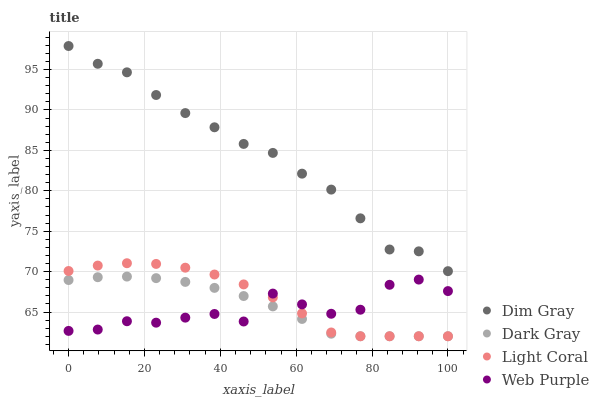Does Web Purple have the minimum area under the curve?
Answer yes or no. Yes. Does Dim Gray have the maximum area under the curve?
Answer yes or no. Yes. Does Light Coral have the minimum area under the curve?
Answer yes or no. No. Does Light Coral have the maximum area under the curve?
Answer yes or no. No. Is Dark Gray the smoothest?
Answer yes or no. Yes. Is Web Purple the roughest?
Answer yes or no. Yes. Is Light Coral the smoothest?
Answer yes or no. No. Is Light Coral the roughest?
Answer yes or no. No. Does Dark Gray have the lowest value?
Answer yes or no. Yes. Does Web Purple have the lowest value?
Answer yes or no. No. Does Dim Gray have the highest value?
Answer yes or no. Yes. Does Light Coral have the highest value?
Answer yes or no. No. Is Web Purple less than Dim Gray?
Answer yes or no. Yes. Is Dim Gray greater than Dark Gray?
Answer yes or no. Yes. Does Web Purple intersect Dark Gray?
Answer yes or no. Yes. Is Web Purple less than Dark Gray?
Answer yes or no. No. Is Web Purple greater than Dark Gray?
Answer yes or no. No. Does Web Purple intersect Dim Gray?
Answer yes or no. No. 